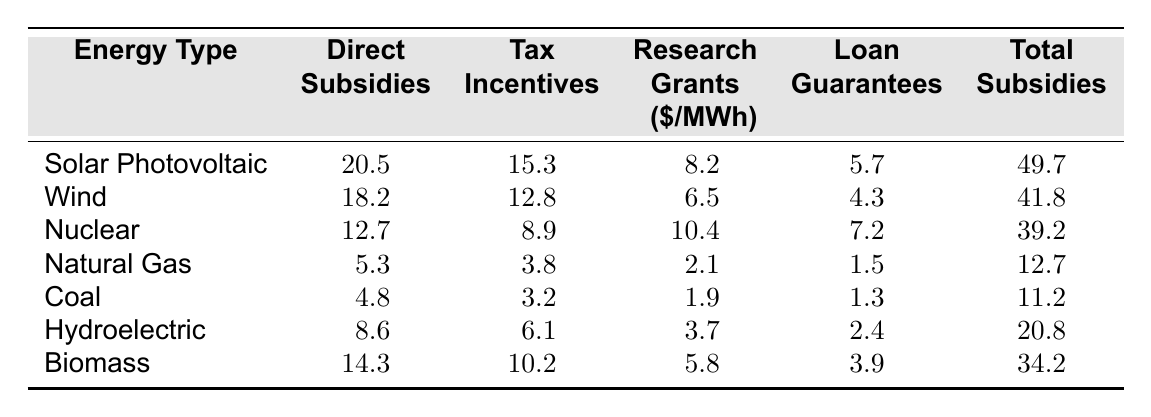What are the direct subsidies for Solar Photovoltaic? The table shows that the direct subsidies for Solar Photovoltaic are 20.5 $/MWh.
Answer: 20.5 Which energy type has the highest total subsidies? By examining the total subsidies column, Solar Photovoltaic has the highest total subsidies at 49.7 $/MWh.
Answer: Solar Photovoltaic What is the difference between the total subsidies for Wind and Coal? The total subsidies for Wind are 41.8 $/MWh, and for Coal, it is 11.2 $/MWh. The difference is 41.8 - 11.2 = 30.6 $/MWh.
Answer: 30.6 What percentage of the total subsidies for Biomass comes from direct subsidies? The total subsidies for Biomass are 34.2 $/MWh, and the direct subsidies are 14.3 $/MWh. The percentage is (14.3 / 34.2) * 100 = 41.8%.
Answer: 41.8% Are the research grants for Nuclear greater than those for Biomass? The research grants for Nuclear are 10.4 $/MWh, and for Biomass, they are 5.8 $/MWh. Since 10.4 > 5.8, the statement is true.
Answer: Yes What is the total amount of direct subsidies for all renewable energy types combined? The renewable energy types are Solar Photovoltaic, Wind, Hydroelectric, and Biomass. Their direct subsidies are: 20.5 + 18.2 + 8.6 + 14.3 = 61.6 $/MWh.
Answer: 61.6 Which energy type has the smallest total subsidies? Coal has the smallest total subsidies of 11.2 $/MWh when comparing all entries in the table.
Answer: Coal If we add the loan guarantees for Nuclear and Wind, what is the sum? The loan guarantees for Nuclear are 7.2 $/MWh and for Wind, they are 4.3 $/MWh. The sum is 7.2 + 4.3 = 11.5 $/MWh.
Answer: 11.5 What is the average total subsidy amount across all the energy types listed? The total subsidies are: 49.7, 41.8, 39.2, 12.7, 11.2, 20.8, and 34.2. Adding these gives 209.6. There are 7 energy types, so the average is 209.6 / 7 = 29.9 $/MWh.
Answer: 29.9 Is it true that Natural Gas receives more total subsidies than Hydroelectric? The total subsidies for Natural Gas are 12.7 $/MWh and for Hydroelectric, they are 20.8 $/MWh. Since 12.7 < 20.8, the statement is false.
Answer: No 